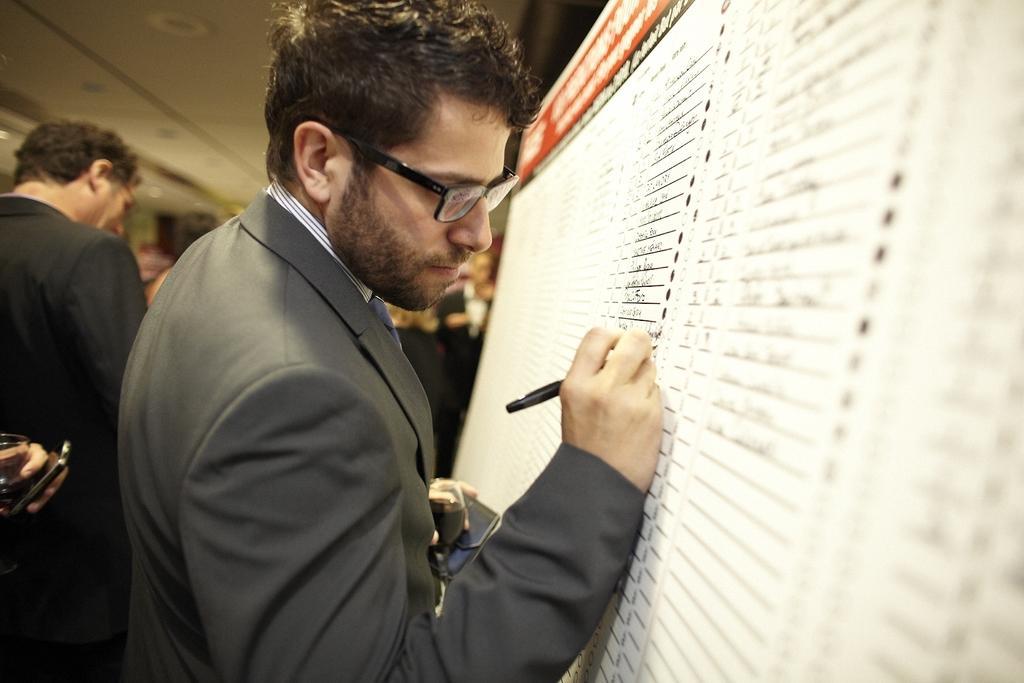Describe this image in one or two sentences. There is a person in suit, holding an object with one hand and holding a pen with other hand and writing on a board. In the background, there are other persons standing on the floor, there is a roof and there are other objects. 